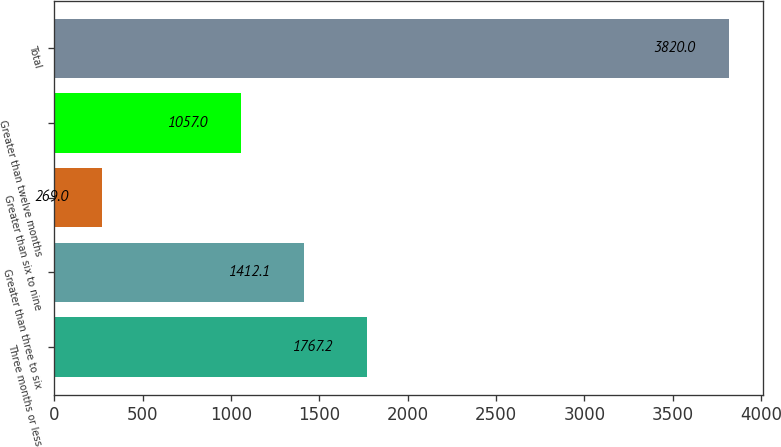Convert chart to OTSL. <chart><loc_0><loc_0><loc_500><loc_500><bar_chart><fcel>Three months or less<fcel>Greater than three to six<fcel>Greater than six to nine<fcel>Greater than twelve months<fcel>Total<nl><fcel>1767.2<fcel>1412.1<fcel>269<fcel>1057<fcel>3820<nl></chart> 